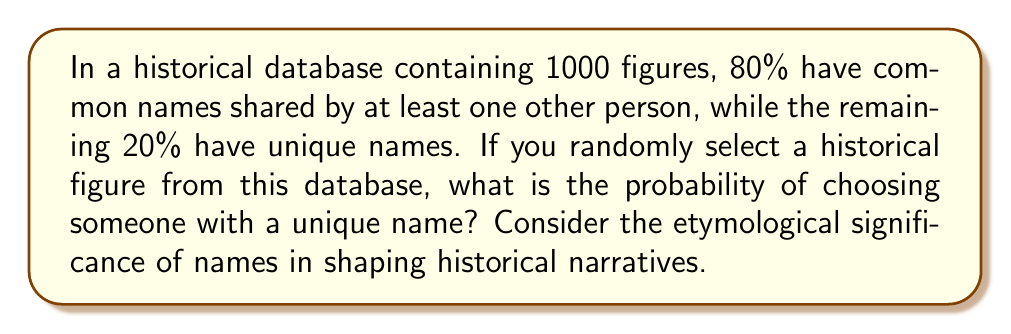Help me with this question. Let's approach this step-by-step:

1) First, let's define our random variable:
   Let $X$ be the event of selecting a historical figure with a unique name.

2) We're given the following information:
   - Total number of historical figures: $n = 1000$
   - Percentage of figures with common names: 80% = 0.80
   - Percentage of figures with unique names: 20% = 0.20

3) To calculate the probability, we need to find the number of favorable outcomes (figures with unique names) and divide it by the total number of possible outcomes (total figures):

   $$P(X) = \frac{\text{Number of figures with unique names}}{\text{Total number of figures}}$$

4) We can calculate the number of figures with unique names:
   $20\% \text{ of } 1000 = 0.20 \times 1000 = 200$

5) Now we can plug this into our probability formula:

   $$P(X) = \frac{200}{1000} = \frac{1}{5} = 0.20$$

This result aligns with the given percentage, which serves as a verification of our calculation.
Answer: $\frac{1}{5}$ or $0.20$ or $20\%$ 